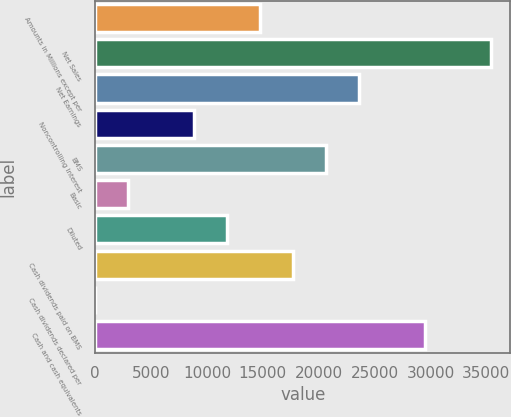Convert chart. <chart><loc_0><loc_0><loc_500><loc_500><bar_chart><fcel>Amounts in Millions except per<fcel>Net Sales<fcel>Net Earnings<fcel>Noncontrolling Interest<fcel>BMS<fcel>Basic<fcel>Diluted<fcel>Cash dividends paid on BMS<fcel>Cash dividends declared per<fcel>Cash and cash equivalents<nl><fcel>14743.6<fcel>35383<fcel>23589.1<fcel>8846.68<fcel>20640.6<fcel>2949.72<fcel>11795.2<fcel>17692.1<fcel>1.24<fcel>29486<nl></chart> 